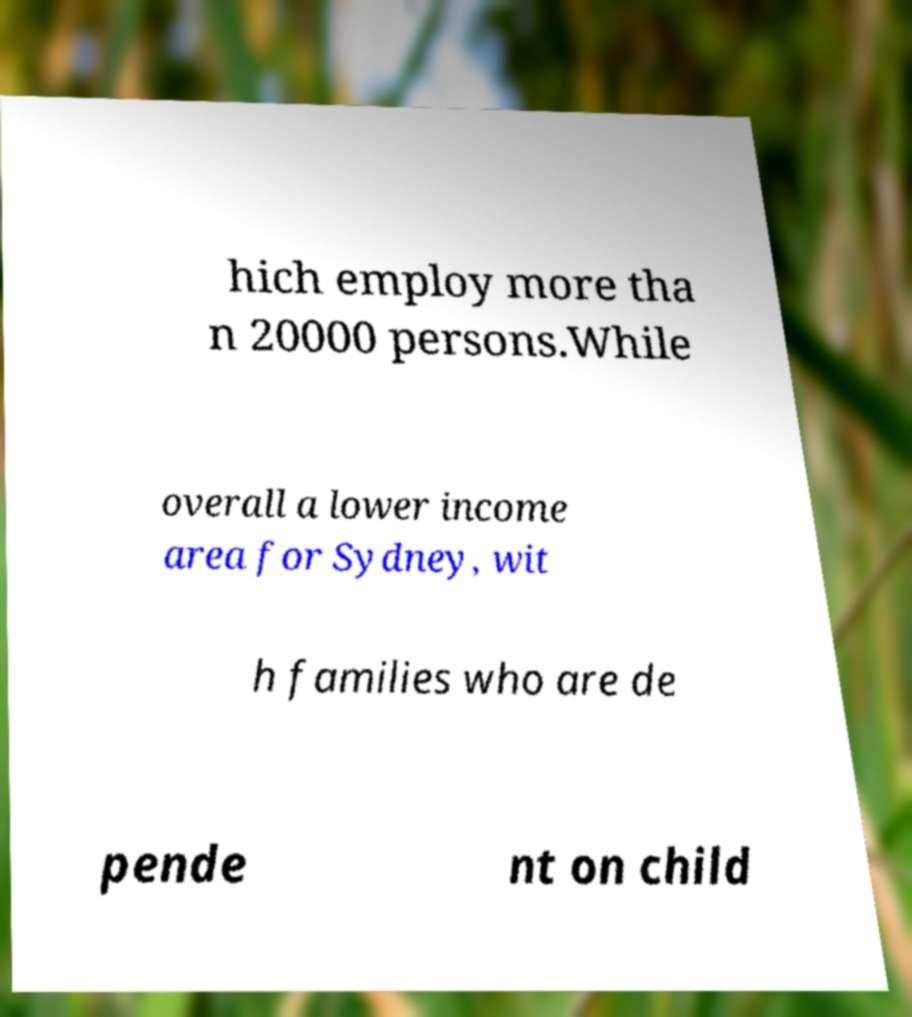Can you accurately transcribe the text from the provided image for me? hich employ more tha n 20000 persons.While overall a lower income area for Sydney, wit h families who are de pende nt on child 